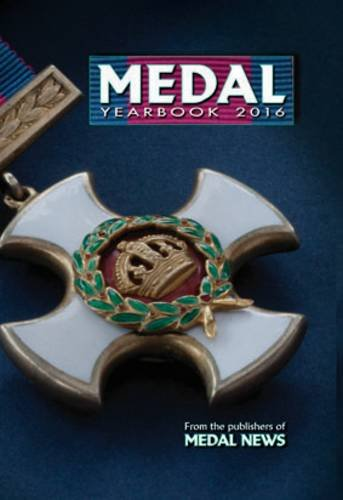Is this a romantic book? No, this book is not a romantic novel; it is a non-fiction reference guide about medals, primarily intended for collectors and historians. 